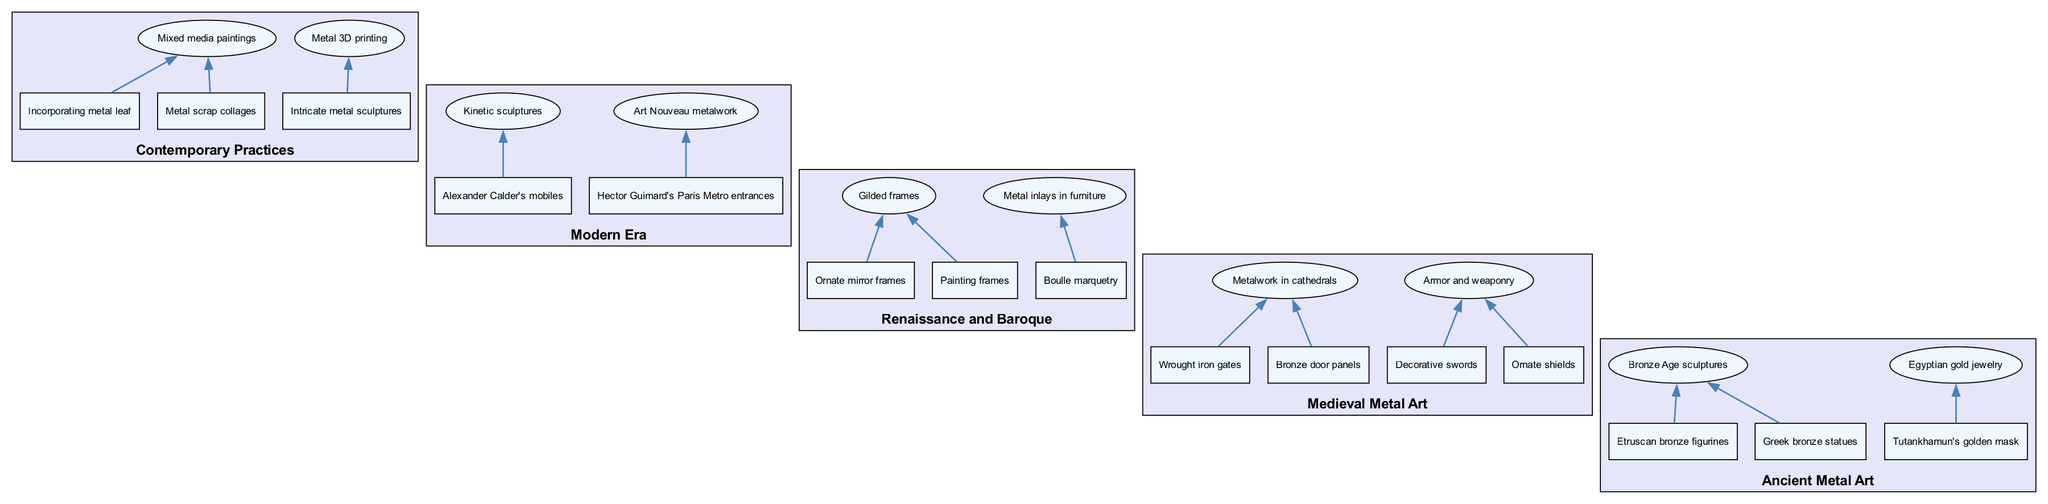What is the first item listed under Ancient Metal Art? The diagram shows that the first item under the "Ancient Metal Art" section is "Bronze Age sculptures." This can be directly read from the node labeled "Ancient Metal Art."
Answer: Bronze Age sculptures How many children does the Medieval Metal Art category have? The diagram indicates that there are two main items under "Medieval Metal Art," each having their own children. The first item has two children, and the second item also has two children, making a total of four children in that category.
Answer: Four What is a decorative element used in Renaissance and Baroque art? The diagram lists "Gilded frames" under the "Renaissance and Baroque" section. This serves as a decorative element that can be easily identified in the diagram.
Answer: Gilded frames What is one example of metalwork found in cathedrals? Under "Medieval Metal Art," the node shows "Wrought iron gates" as one of the children's examples related to metalwork in cathedrals. This can be identified directly from the flow of the diagram in the specified section.
Answer: Wrought iron gates Which modern artist is associated with Kinetic sculptures? The diagram indicates that "Alexander Calder's mobiles" is an example of Kinetic sculptures under the "Modern Era." This information can be found by tracing the Modern Era section and observing the listed children.
Answer: Alexander Calder What category includes "Tutankhamun's golden mask"? According to the diagram, "Tutankhamun's golden mask" is listed as a child under "Egyptian gold jewelry," which is a part of the "Ancient Metal Art" section. This relationship is clear in the diagram's structure.
Answer: Ancient Metal Art How many eras of metal usage in art are represented in the diagram? The diagram outlines five distinct eras: Ancient Metal Art, Medieval Metal Art, Renaissance and Baroque, Modern Era, and Contemporary Practices. Each is clearly titled in the diagram as separate sections.
Answer: Five What technique is used for "Mixed media paintings"? Within the "Contemporary Practices" category, the diagram lists "Incorporating metal leaf" and "Metal scrap collages." The first technique directly states the use of metal leaf as part of the mixed media art form.
Answer: Incorporating metal leaf 